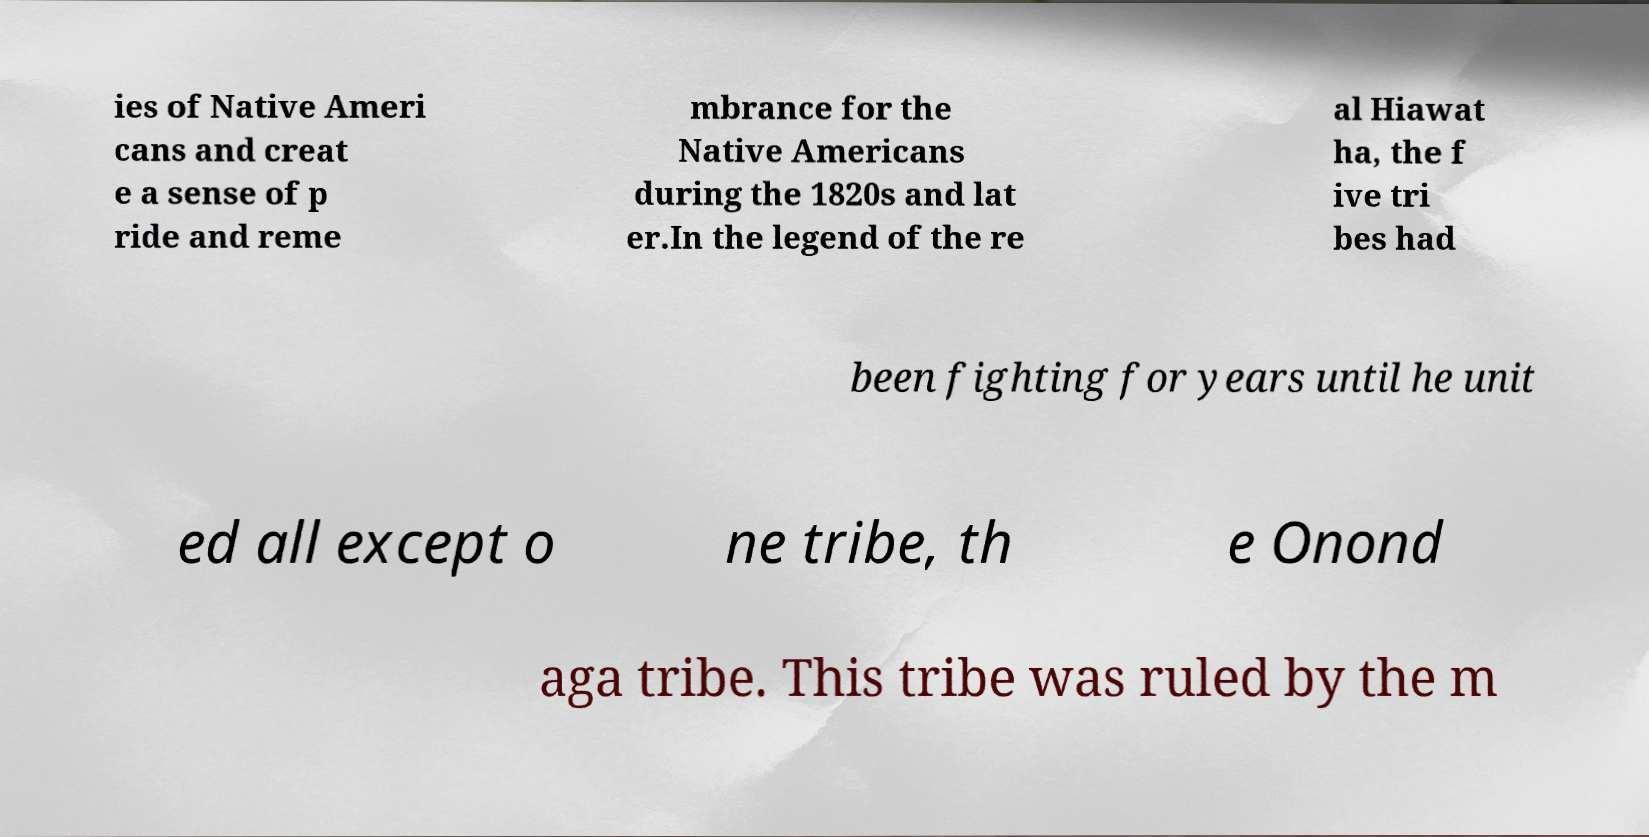Can you accurately transcribe the text from the provided image for me? ies of Native Ameri cans and creat e a sense of p ride and reme mbrance for the Native Americans during the 1820s and lat er.In the legend of the re al Hiawat ha, the f ive tri bes had been fighting for years until he unit ed all except o ne tribe, th e Onond aga tribe. This tribe was ruled by the m 